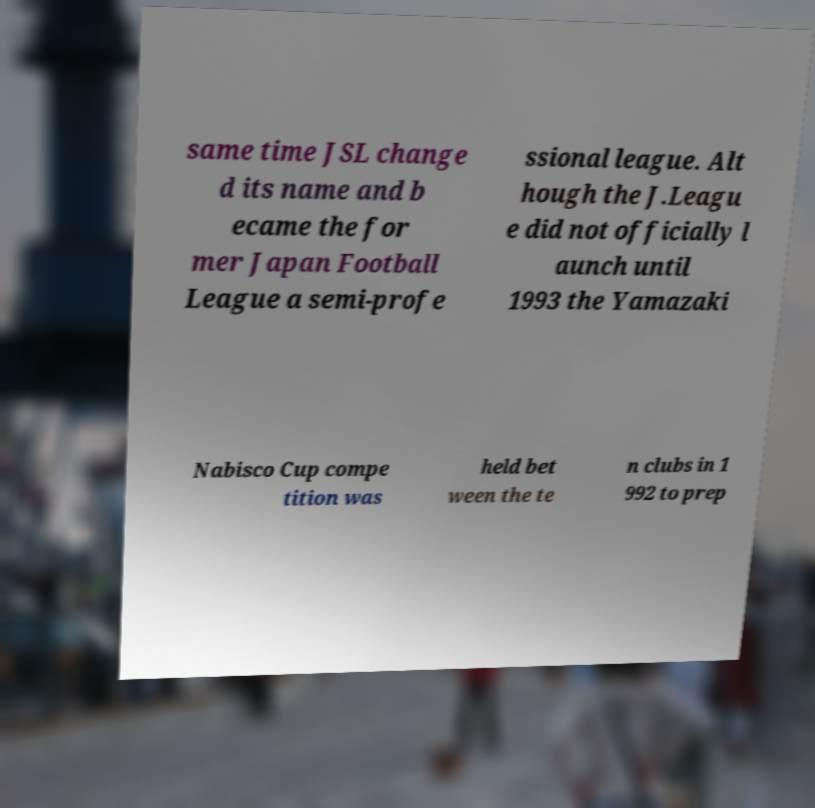Could you assist in decoding the text presented in this image and type it out clearly? same time JSL change d its name and b ecame the for mer Japan Football League a semi-profe ssional league. Alt hough the J.Leagu e did not officially l aunch until 1993 the Yamazaki Nabisco Cup compe tition was held bet ween the te n clubs in 1 992 to prep 